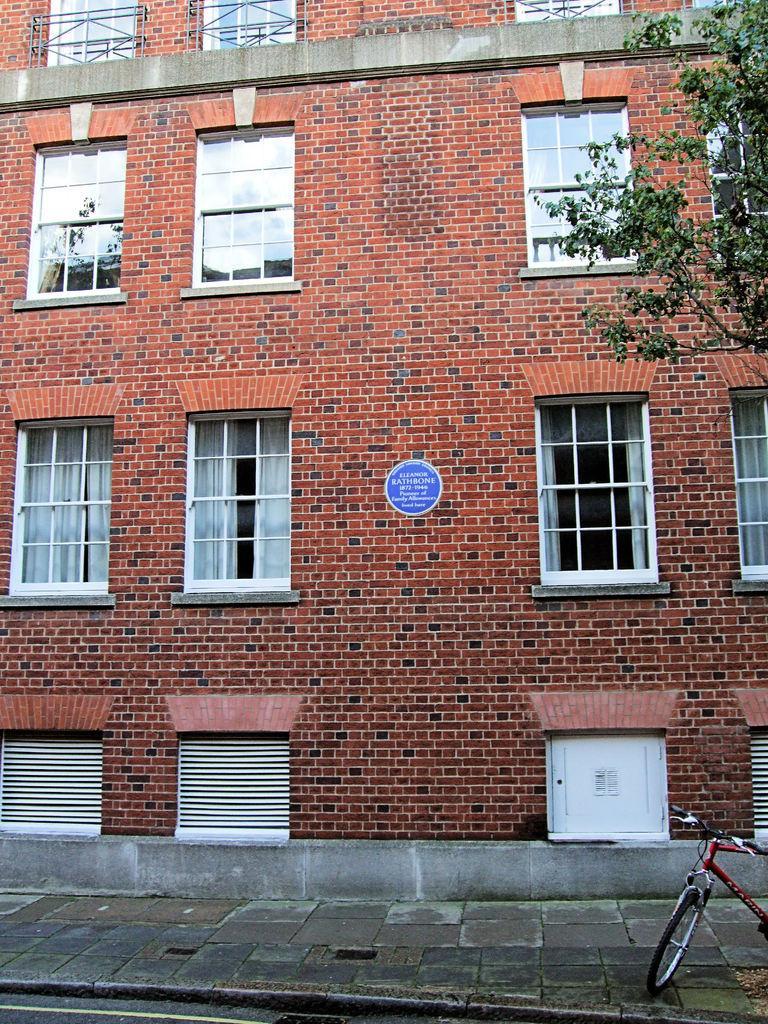Describe this image in one or two sentences. This image consists of a building in brown color along with windows. At the bottom, there is a pavement. To the right, there is a bicycle and a tree. 